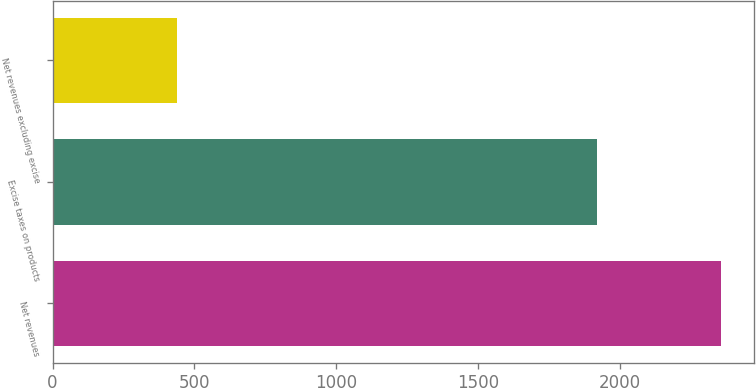<chart> <loc_0><loc_0><loc_500><loc_500><bar_chart><fcel>Net revenues<fcel>Excise taxes on products<fcel>Net revenues excluding excise<nl><fcel>2355<fcel>1918<fcel>437<nl></chart> 